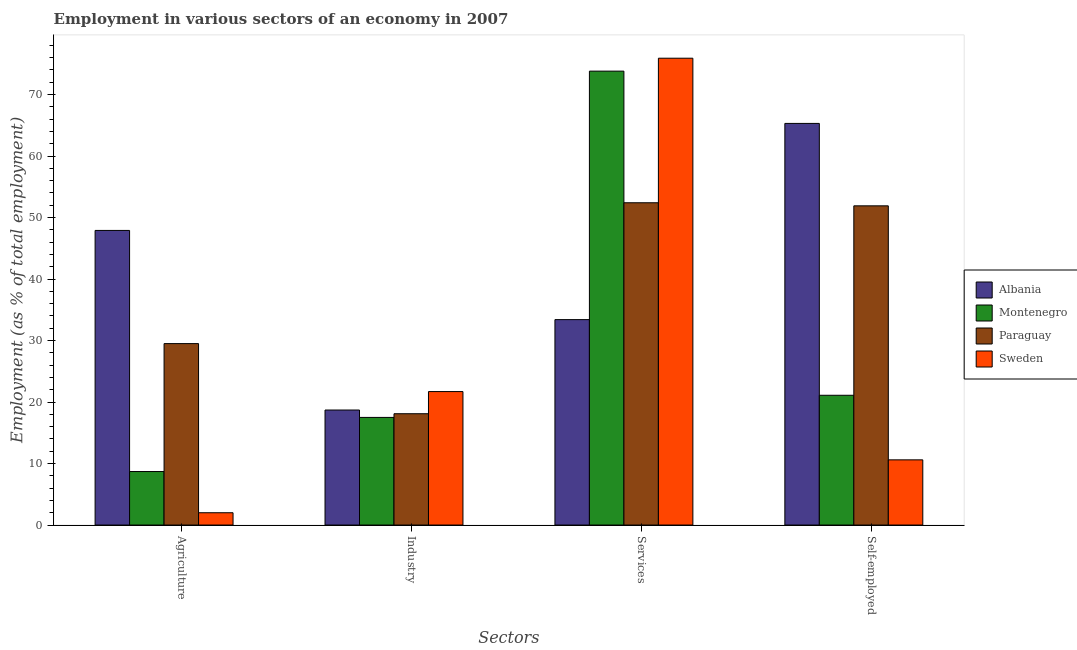How many groups of bars are there?
Keep it short and to the point. 4. How many bars are there on the 3rd tick from the right?
Provide a short and direct response. 4. What is the label of the 2nd group of bars from the left?
Offer a very short reply. Industry. What is the percentage of workers in agriculture in Montenegro?
Your answer should be very brief. 8.7. Across all countries, what is the maximum percentage of self employed workers?
Your answer should be compact. 65.3. Across all countries, what is the minimum percentage of workers in industry?
Keep it short and to the point. 17.5. In which country was the percentage of workers in industry maximum?
Your answer should be very brief. Sweden. In which country was the percentage of workers in industry minimum?
Your answer should be compact. Montenegro. What is the total percentage of workers in industry in the graph?
Offer a terse response. 76. What is the difference between the percentage of self employed workers in Montenegro and that in Paraguay?
Provide a succinct answer. -30.8. What is the difference between the percentage of workers in industry in Paraguay and the percentage of workers in agriculture in Albania?
Your answer should be compact. -29.8. What is the average percentage of workers in industry per country?
Offer a very short reply. 19. What is the difference between the percentage of workers in industry and percentage of workers in agriculture in Montenegro?
Make the answer very short. 8.8. What is the ratio of the percentage of workers in industry in Sweden to that in Paraguay?
Give a very brief answer. 1.2. Is the percentage of workers in industry in Sweden less than that in Paraguay?
Make the answer very short. No. What is the difference between the highest and the second highest percentage of workers in agriculture?
Offer a very short reply. 18.4. What is the difference between the highest and the lowest percentage of workers in industry?
Your response must be concise. 4.2. What does the 4th bar from the right in Agriculture represents?
Offer a terse response. Albania. How many bars are there?
Ensure brevity in your answer.  16. How many countries are there in the graph?
Offer a terse response. 4. Does the graph contain any zero values?
Your response must be concise. No. Does the graph contain grids?
Offer a terse response. No. Where does the legend appear in the graph?
Offer a very short reply. Center right. How many legend labels are there?
Keep it short and to the point. 4. What is the title of the graph?
Give a very brief answer. Employment in various sectors of an economy in 2007. What is the label or title of the X-axis?
Provide a short and direct response. Sectors. What is the label or title of the Y-axis?
Your answer should be very brief. Employment (as % of total employment). What is the Employment (as % of total employment) in Albania in Agriculture?
Make the answer very short. 47.9. What is the Employment (as % of total employment) in Montenegro in Agriculture?
Ensure brevity in your answer.  8.7. What is the Employment (as % of total employment) of Paraguay in Agriculture?
Your response must be concise. 29.5. What is the Employment (as % of total employment) in Sweden in Agriculture?
Ensure brevity in your answer.  2. What is the Employment (as % of total employment) in Albania in Industry?
Offer a very short reply. 18.7. What is the Employment (as % of total employment) of Paraguay in Industry?
Offer a very short reply. 18.1. What is the Employment (as % of total employment) of Sweden in Industry?
Provide a short and direct response. 21.7. What is the Employment (as % of total employment) in Albania in Services?
Offer a very short reply. 33.4. What is the Employment (as % of total employment) of Montenegro in Services?
Your response must be concise. 73.8. What is the Employment (as % of total employment) of Paraguay in Services?
Give a very brief answer. 52.4. What is the Employment (as % of total employment) in Sweden in Services?
Make the answer very short. 75.9. What is the Employment (as % of total employment) of Albania in Self-employed?
Offer a terse response. 65.3. What is the Employment (as % of total employment) in Montenegro in Self-employed?
Your answer should be very brief. 21.1. What is the Employment (as % of total employment) in Paraguay in Self-employed?
Keep it short and to the point. 51.9. What is the Employment (as % of total employment) in Sweden in Self-employed?
Give a very brief answer. 10.6. Across all Sectors, what is the maximum Employment (as % of total employment) in Albania?
Give a very brief answer. 65.3. Across all Sectors, what is the maximum Employment (as % of total employment) of Montenegro?
Your answer should be very brief. 73.8. Across all Sectors, what is the maximum Employment (as % of total employment) of Paraguay?
Keep it short and to the point. 52.4. Across all Sectors, what is the maximum Employment (as % of total employment) in Sweden?
Your response must be concise. 75.9. Across all Sectors, what is the minimum Employment (as % of total employment) of Albania?
Provide a short and direct response. 18.7. Across all Sectors, what is the minimum Employment (as % of total employment) of Montenegro?
Ensure brevity in your answer.  8.7. Across all Sectors, what is the minimum Employment (as % of total employment) of Paraguay?
Provide a succinct answer. 18.1. Across all Sectors, what is the minimum Employment (as % of total employment) in Sweden?
Provide a succinct answer. 2. What is the total Employment (as % of total employment) in Albania in the graph?
Ensure brevity in your answer.  165.3. What is the total Employment (as % of total employment) of Montenegro in the graph?
Your response must be concise. 121.1. What is the total Employment (as % of total employment) of Paraguay in the graph?
Provide a short and direct response. 151.9. What is the total Employment (as % of total employment) of Sweden in the graph?
Give a very brief answer. 110.2. What is the difference between the Employment (as % of total employment) of Albania in Agriculture and that in Industry?
Give a very brief answer. 29.2. What is the difference between the Employment (as % of total employment) of Montenegro in Agriculture and that in Industry?
Your response must be concise. -8.8. What is the difference between the Employment (as % of total employment) in Sweden in Agriculture and that in Industry?
Provide a succinct answer. -19.7. What is the difference between the Employment (as % of total employment) in Montenegro in Agriculture and that in Services?
Keep it short and to the point. -65.1. What is the difference between the Employment (as % of total employment) of Paraguay in Agriculture and that in Services?
Your answer should be very brief. -22.9. What is the difference between the Employment (as % of total employment) of Sweden in Agriculture and that in Services?
Keep it short and to the point. -73.9. What is the difference between the Employment (as % of total employment) of Albania in Agriculture and that in Self-employed?
Offer a terse response. -17.4. What is the difference between the Employment (as % of total employment) in Paraguay in Agriculture and that in Self-employed?
Ensure brevity in your answer.  -22.4. What is the difference between the Employment (as % of total employment) of Sweden in Agriculture and that in Self-employed?
Give a very brief answer. -8.6. What is the difference between the Employment (as % of total employment) of Albania in Industry and that in Services?
Your answer should be compact. -14.7. What is the difference between the Employment (as % of total employment) of Montenegro in Industry and that in Services?
Provide a short and direct response. -56.3. What is the difference between the Employment (as % of total employment) of Paraguay in Industry and that in Services?
Offer a very short reply. -34.3. What is the difference between the Employment (as % of total employment) of Sweden in Industry and that in Services?
Your answer should be compact. -54.2. What is the difference between the Employment (as % of total employment) of Albania in Industry and that in Self-employed?
Your answer should be compact. -46.6. What is the difference between the Employment (as % of total employment) in Montenegro in Industry and that in Self-employed?
Offer a very short reply. -3.6. What is the difference between the Employment (as % of total employment) of Paraguay in Industry and that in Self-employed?
Provide a short and direct response. -33.8. What is the difference between the Employment (as % of total employment) of Sweden in Industry and that in Self-employed?
Offer a very short reply. 11.1. What is the difference between the Employment (as % of total employment) in Albania in Services and that in Self-employed?
Give a very brief answer. -31.9. What is the difference between the Employment (as % of total employment) of Montenegro in Services and that in Self-employed?
Your response must be concise. 52.7. What is the difference between the Employment (as % of total employment) of Paraguay in Services and that in Self-employed?
Provide a succinct answer. 0.5. What is the difference between the Employment (as % of total employment) of Sweden in Services and that in Self-employed?
Offer a terse response. 65.3. What is the difference between the Employment (as % of total employment) in Albania in Agriculture and the Employment (as % of total employment) in Montenegro in Industry?
Your response must be concise. 30.4. What is the difference between the Employment (as % of total employment) of Albania in Agriculture and the Employment (as % of total employment) of Paraguay in Industry?
Provide a succinct answer. 29.8. What is the difference between the Employment (as % of total employment) of Albania in Agriculture and the Employment (as % of total employment) of Sweden in Industry?
Ensure brevity in your answer.  26.2. What is the difference between the Employment (as % of total employment) of Montenegro in Agriculture and the Employment (as % of total employment) of Sweden in Industry?
Your answer should be very brief. -13. What is the difference between the Employment (as % of total employment) in Paraguay in Agriculture and the Employment (as % of total employment) in Sweden in Industry?
Provide a short and direct response. 7.8. What is the difference between the Employment (as % of total employment) of Albania in Agriculture and the Employment (as % of total employment) of Montenegro in Services?
Your answer should be very brief. -25.9. What is the difference between the Employment (as % of total employment) of Albania in Agriculture and the Employment (as % of total employment) of Paraguay in Services?
Offer a terse response. -4.5. What is the difference between the Employment (as % of total employment) in Montenegro in Agriculture and the Employment (as % of total employment) in Paraguay in Services?
Ensure brevity in your answer.  -43.7. What is the difference between the Employment (as % of total employment) in Montenegro in Agriculture and the Employment (as % of total employment) in Sweden in Services?
Make the answer very short. -67.2. What is the difference between the Employment (as % of total employment) in Paraguay in Agriculture and the Employment (as % of total employment) in Sweden in Services?
Offer a terse response. -46.4. What is the difference between the Employment (as % of total employment) in Albania in Agriculture and the Employment (as % of total employment) in Montenegro in Self-employed?
Keep it short and to the point. 26.8. What is the difference between the Employment (as % of total employment) of Albania in Agriculture and the Employment (as % of total employment) of Sweden in Self-employed?
Provide a succinct answer. 37.3. What is the difference between the Employment (as % of total employment) of Montenegro in Agriculture and the Employment (as % of total employment) of Paraguay in Self-employed?
Ensure brevity in your answer.  -43.2. What is the difference between the Employment (as % of total employment) of Montenegro in Agriculture and the Employment (as % of total employment) of Sweden in Self-employed?
Your response must be concise. -1.9. What is the difference between the Employment (as % of total employment) in Paraguay in Agriculture and the Employment (as % of total employment) in Sweden in Self-employed?
Make the answer very short. 18.9. What is the difference between the Employment (as % of total employment) of Albania in Industry and the Employment (as % of total employment) of Montenegro in Services?
Make the answer very short. -55.1. What is the difference between the Employment (as % of total employment) in Albania in Industry and the Employment (as % of total employment) in Paraguay in Services?
Offer a very short reply. -33.7. What is the difference between the Employment (as % of total employment) in Albania in Industry and the Employment (as % of total employment) in Sweden in Services?
Make the answer very short. -57.2. What is the difference between the Employment (as % of total employment) of Montenegro in Industry and the Employment (as % of total employment) of Paraguay in Services?
Your answer should be very brief. -34.9. What is the difference between the Employment (as % of total employment) in Montenegro in Industry and the Employment (as % of total employment) in Sweden in Services?
Ensure brevity in your answer.  -58.4. What is the difference between the Employment (as % of total employment) in Paraguay in Industry and the Employment (as % of total employment) in Sweden in Services?
Offer a very short reply. -57.8. What is the difference between the Employment (as % of total employment) in Albania in Industry and the Employment (as % of total employment) in Montenegro in Self-employed?
Provide a short and direct response. -2.4. What is the difference between the Employment (as % of total employment) of Albania in Industry and the Employment (as % of total employment) of Paraguay in Self-employed?
Your response must be concise. -33.2. What is the difference between the Employment (as % of total employment) in Albania in Industry and the Employment (as % of total employment) in Sweden in Self-employed?
Offer a very short reply. 8.1. What is the difference between the Employment (as % of total employment) of Montenegro in Industry and the Employment (as % of total employment) of Paraguay in Self-employed?
Give a very brief answer. -34.4. What is the difference between the Employment (as % of total employment) of Paraguay in Industry and the Employment (as % of total employment) of Sweden in Self-employed?
Offer a terse response. 7.5. What is the difference between the Employment (as % of total employment) in Albania in Services and the Employment (as % of total employment) in Paraguay in Self-employed?
Your answer should be very brief. -18.5. What is the difference between the Employment (as % of total employment) in Albania in Services and the Employment (as % of total employment) in Sweden in Self-employed?
Your answer should be compact. 22.8. What is the difference between the Employment (as % of total employment) of Montenegro in Services and the Employment (as % of total employment) of Paraguay in Self-employed?
Your response must be concise. 21.9. What is the difference between the Employment (as % of total employment) in Montenegro in Services and the Employment (as % of total employment) in Sweden in Self-employed?
Your answer should be compact. 63.2. What is the difference between the Employment (as % of total employment) of Paraguay in Services and the Employment (as % of total employment) of Sweden in Self-employed?
Ensure brevity in your answer.  41.8. What is the average Employment (as % of total employment) of Albania per Sectors?
Make the answer very short. 41.33. What is the average Employment (as % of total employment) in Montenegro per Sectors?
Your answer should be compact. 30.27. What is the average Employment (as % of total employment) of Paraguay per Sectors?
Your answer should be very brief. 37.98. What is the average Employment (as % of total employment) of Sweden per Sectors?
Offer a terse response. 27.55. What is the difference between the Employment (as % of total employment) of Albania and Employment (as % of total employment) of Montenegro in Agriculture?
Make the answer very short. 39.2. What is the difference between the Employment (as % of total employment) of Albania and Employment (as % of total employment) of Paraguay in Agriculture?
Give a very brief answer. 18.4. What is the difference between the Employment (as % of total employment) of Albania and Employment (as % of total employment) of Sweden in Agriculture?
Keep it short and to the point. 45.9. What is the difference between the Employment (as % of total employment) in Montenegro and Employment (as % of total employment) in Paraguay in Agriculture?
Your answer should be very brief. -20.8. What is the difference between the Employment (as % of total employment) in Paraguay and Employment (as % of total employment) in Sweden in Agriculture?
Ensure brevity in your answer.  27.5. What is the difference between the Employment (as % of total employment) in Albania and Employment (as % of total employment) in Montenegro in Industry?
Offer a terse response. 1.2. What is the difference between the Employment (as % of total employment) in Paraguay and Employment (as % of total employment) in Sweden in Industry?
Provide a short and direct response. -3.6. What is the difference between the Employment (as % of total employment) in Albania and Employment (as % of total employment) in Montenegro in Services?
Your response must be concise. -40.4. What is the difference between the Employment (as % of total employment) of Albania and Employment (as % of total employment) of Paraguay in Services?
Make the answer very short. -19. What is the difference between the Employment (as % of total employment) of Albania and Employment (as % of total employment) of Sweden in Services?
Your answer should be compact. -42.5. What is the difference between the Employment (as % of total employment) of Montenegro and Employment (as % of total employment) of Paraguay in Services?
Make the answer very short. 21.4. What is the difference between the Employment (as % of total employment) in Montenegro and Employment (as % of total employment) in Sweden in Services?
Your answer should be compact. -2.1. What is the difference between the Employment (as % of total employment) in Paraguay and Employment (as % of total employment) in Sweden in Services?
Offer a very short reply. -23.5. What is the difference between the Employment (as % of total employment) of Albania and Employment (as % of total employment) of Montenegro in Self-employed?
Keep it short and to the point. 44.2. What is the difference between the Employment (as % of total employment) of Albania and Employment (as % of total employment) of Paraguay in Self-employed?
Provide a succinct answer. 13.4. What is the difference between the Employment (as % of total employment) of Albania and Employment (as % of total employment) of Sweden in Self-employed?
Your response must be concise. 54.7. What is the difference between the Employment (as % of total employment) of Montenegro and Employment (as % of total employment) of Paraguay in Self-employed?
Keep it short and to the point. -30.8. What is the difference between the Employment (as % of total employment) in Montenegro and Employment (as % of total employment) in Sweden in Self-employed?
Offer a terse response. 10.5. What is the difference between the Employment (as % of total employment) of Paraguay and Employment (as % of total employment) of Sweden in Self-employed?
Your response must be concise. 41.3. What is the ratio of the Employment (as % of total employment) of Albania in Agriculture to that in Industry?
Give a very brief answer. 2.56. What is the ratio of the Employment (as % of total employment) of Montenegro in Agriculture to that in Industry?
Make the answer very short. 0.5. What is the ratio of the Employment (as % of total employment) in Paraguay in Agriculture to that in Industry?
Provide a succinct answer. 1.63. What is the ratio of the Employment (as % of total employment) in Sweden in Agriculture to that in Industry?
Make the answer very short. 0.09. What is the ratio of the Employment (as % of total employment) of Albania in Agriculture to that in Services?
Provide a short and direct response. 1.43. What is the ratio of the Employment (as % of total employment) of Montenegro in Agriculture to that in Services?
Ensure brevity in your answer.  0.12. What is the ratio of the Employment (as % of total employment) in Paraguay in Agriculture to that in Services?
Provide a short and direct response. 0.56. What is the ratio of the Employment (as % of total employment) of Sweden in Agriculture to that in Services?
Your answer should be compact. 0.03. What is the ratio of the Employment (as % of total employment) in Albania in Agriculture to that in Self-employed?
Your answer should be compact. 0.73. What is the ratio of the Employment (as % of total employment) of Montenegro in Agriculture to that in Self-employed?
Make the answer very short. 0.41. What is the ratio of the Employment (as % of total employment) in Paraguay in Agriculture to that in Self-employed?
Provide a succinct answer. 0.57. What is the ratio of the Employment (as % of total employment) of Sweden in Agriculture to that in Self-employed?
Offer a terse response. 0.19. What is the ratio of the Employment (as % of total employment) of Albania in Industry to that in Services?
Offer a terse response. 0.56. What is the ratio of the Employment (as % of total employment) in Montenegro in Industry to that in Services?
Your response must be concise. 0.24. What is the ratio of the Employment (as % of total employment) of Paraguay in Industry to that in Services?
Offer a very short reply. 0.35. What is the ratio of the Employment (as % of total employment) of Sweden in Industry to that in Services?
Provide a succinct answer. 0.29. What is the ratio of the Employment (as % of total employment) in Albania in Industry to that in Self-employed?
Your answer should be very brief. 0.29. What is the ratio of the Employment (as % of total employment) in Montenegro in Industry to that in Self-employed?
Make the answer very short. 0.83. What is the ratio of the Employment (as % of total employment) of Paraguay in Industry to that in Self-employed?
Ensure brevity in your answer.  0.35. What is the ratio of the Employment (as % of total employment) of Sweden in Industry to that in Self-employed?
Keep it short and to the point. 2.05. What is the ratio of the Employment (as % of total employment) of Albania in Services to that in Self-employed?
Provide a succinct answer. 0.51. What is the ratio of the Employment (as % of total employment) of Montenegro in Services to that in Self-employed?
Your answer should be very brief. 3.5. What is the ratio of the Employment (as % of total employment) in Paraguay in Services to that in Self-employed?
Offer a very short reply. 1.01. What is the ratio of the Employment (as % of total employment) of Sweden in Services to that in Self-employed?
Your answer should be compact. 7.16. What is the difference between the highest and the second highest Employment (as % of total employment) of Montenegro?
Provide a succinct answer. 52.7. What is the difference between the highest and the second highest Employment (as % of total employment) in Sweden?
Ensure brevity in your answer.  54.2. What is the difference between the highest and the lowest Employment (as % of total employment) of Albania?
Your answer should be very brief. 46.6. What is the difference between the highest and the lowest Employment (as % of total employment) in Montenegro?
Provide a succinct answer. 65.1. What is the difference between the highest and the lowest Employment (as % of total employment) in Paraguay?
Provide a succinct answer. 34.3. What is the difference between the highest and the lowest Employment (as % of total employment) of Sweden?
Offer a very short reply. 73.9. 